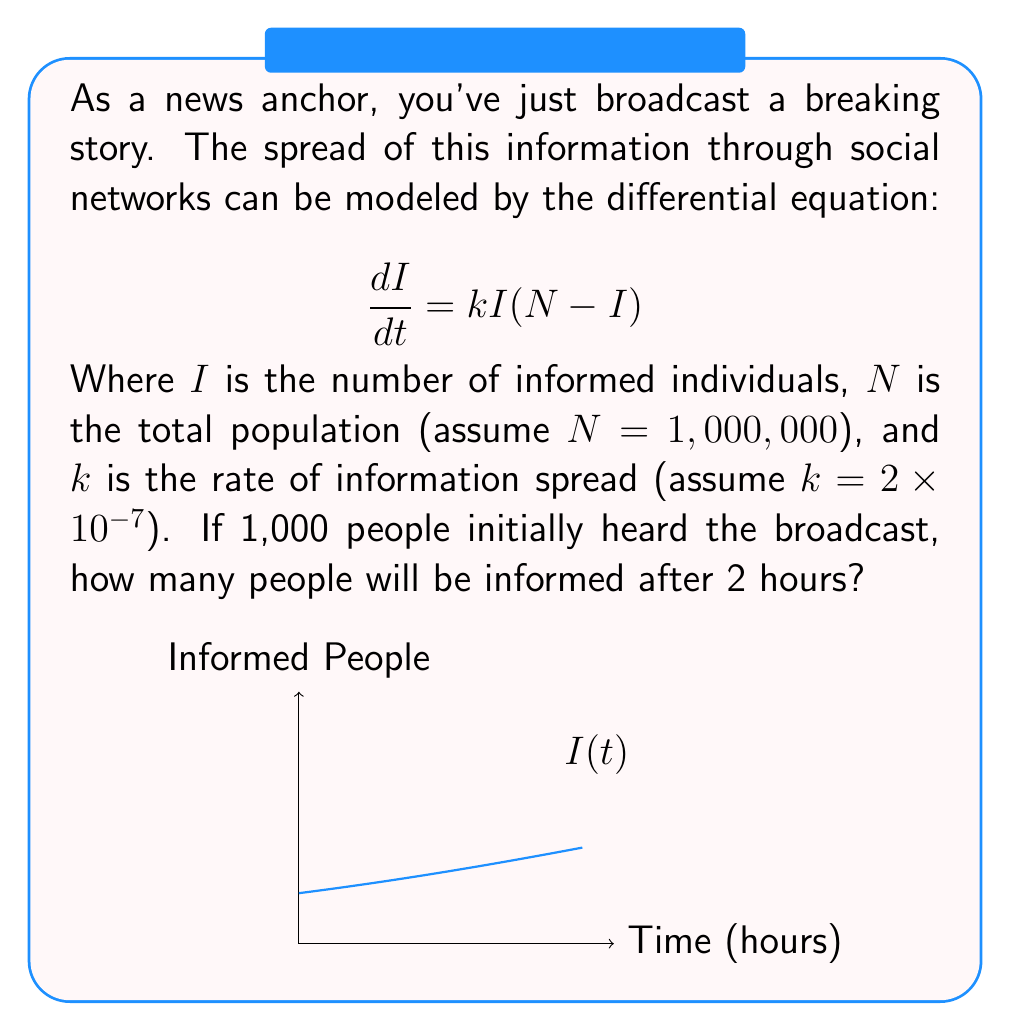Could you help me with this problem? Let's solve this step-by-step:

1) The given differential equation is a logistic growth model:
   $$\frac{dI}{dt} = kI(N-I)$$

2) The solution to this equation is:
   $$I(t) = \frac{N}{1 + (\frac{N}{I_0} - 1)e^{-kNt}}$$

   Where $I_0$ is the initial number of informed people.

3) We're given:
   $N = 1,000,000$
   $k = 2 \times 10^{-7}$
   $I_0 = 1,000$
   $t = 2$ hours

4) Let's substitute these values:
   $$I(2) = \frac{1,000,000}{1 + (\frac{1,000,000}{1,000} - 1)e^{-(2 \times 10^{-7})(1,000,000)(2)}}$$

5) Simplify:
   $$I(2) = \frac{1,000,000}{1 + 999e^{-0.4}}$$

6) Calculate:
   $$I(2) \approx 329,289$$

Therefore, after 2 hours, approximately 329,289 people will be informed.
Answer: 329,289 people 